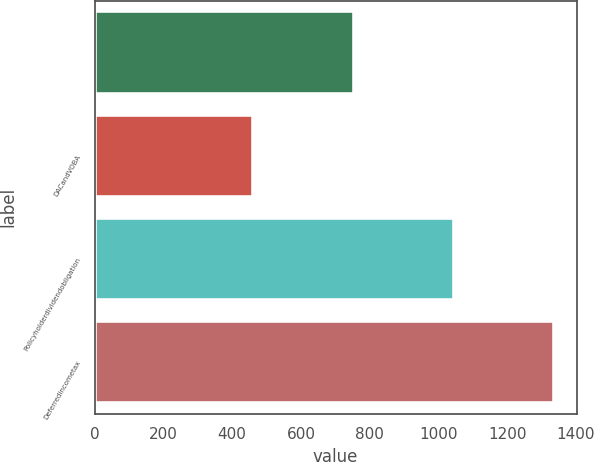Convert chart to OTSL. <chart><loc_0><loc_0><loc_500><loc_500><bar_chart><ecel><fcel>DACandVOBA<fcel>Policyholderdividendobligation<fcel>Deferredincometax<nl><fcel>753<fcel>462<fcel>1044<fcel>1335<nl></chart> 